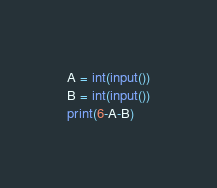<code> <loc_0><loc_0><loc_500><loc_500><_Python_>A = int(input())
B = int(input())
print(6-A-B)
</code> 